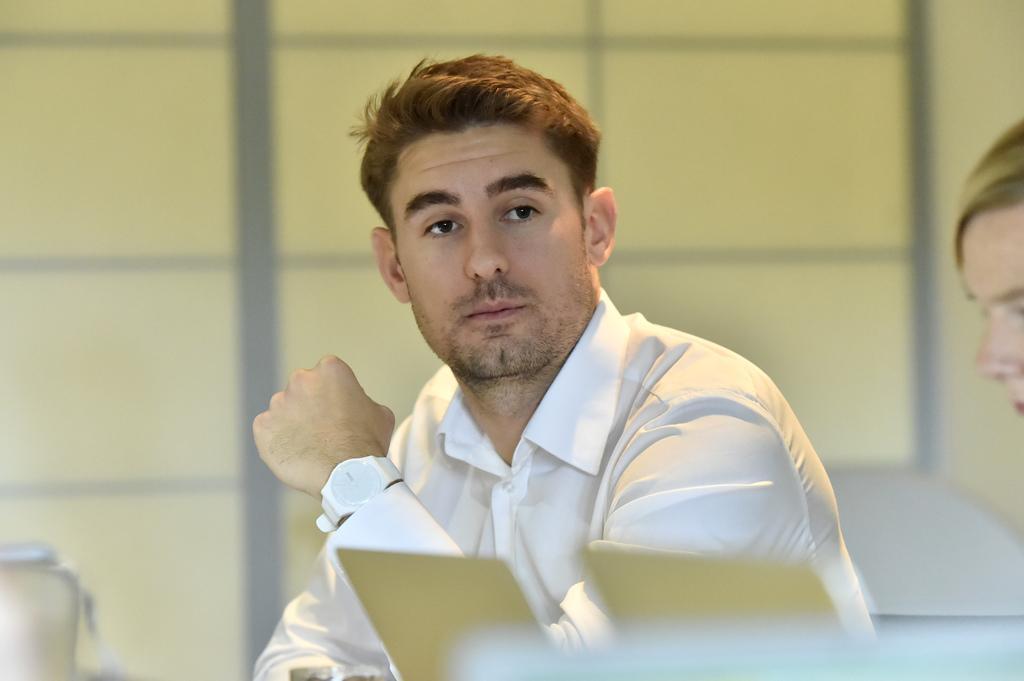In one or two sentences, can you explain what this image depicts? In this image we can see a man and a woman. 